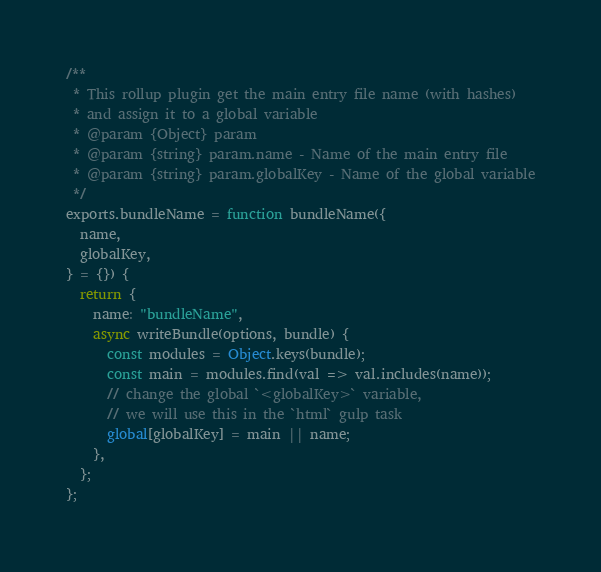<code> <loc_0><loc_0><loc_500><loc_500><_JavaScript_>/**
 * This rollup plugin get the main entry file name (with hashes)
 * and assign it to a global variable
 * @param {Object} param
 * @param {string} param.name - Name of the main entry file
 * @param {string} param.globalKey - Name of the global variable
 */
exports.bundleName = function bundleName({
  name,
  globalKey,
} = {}) {
  return {
    name: "bundleName",
    async writeBundle(options, bundle) {
      const modules = Object.keys(bundle);
      const main = modules.find(val => val.includes(name));
      // change the global `<globalKey>` variable,
      // we will use this in the `html` gulp task
      global[globalKey] = main || name;
    },
  };
};
</code> 